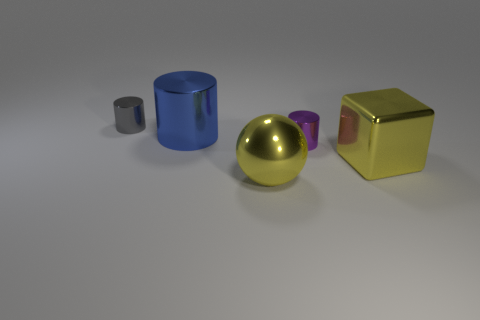Add 2 small purple cylinders. How many objects exist? 7 Subtract all brown cylinders. Subtract all red balls. How many cylinders are left? 3 Subtract all spheres. How many objects are left? 4 Add 5 yellow metal cubes. How many yellow metal cubes are left? 6 Add 4 yellow metallic objects. How many yellow metallic objects exist? 6 Subtract 1 yellow blocks. How many objects are left? 4 Subtract all yellow rubber cylinders. Subtract all tiny purple cylinders. How many objects are left? 4 